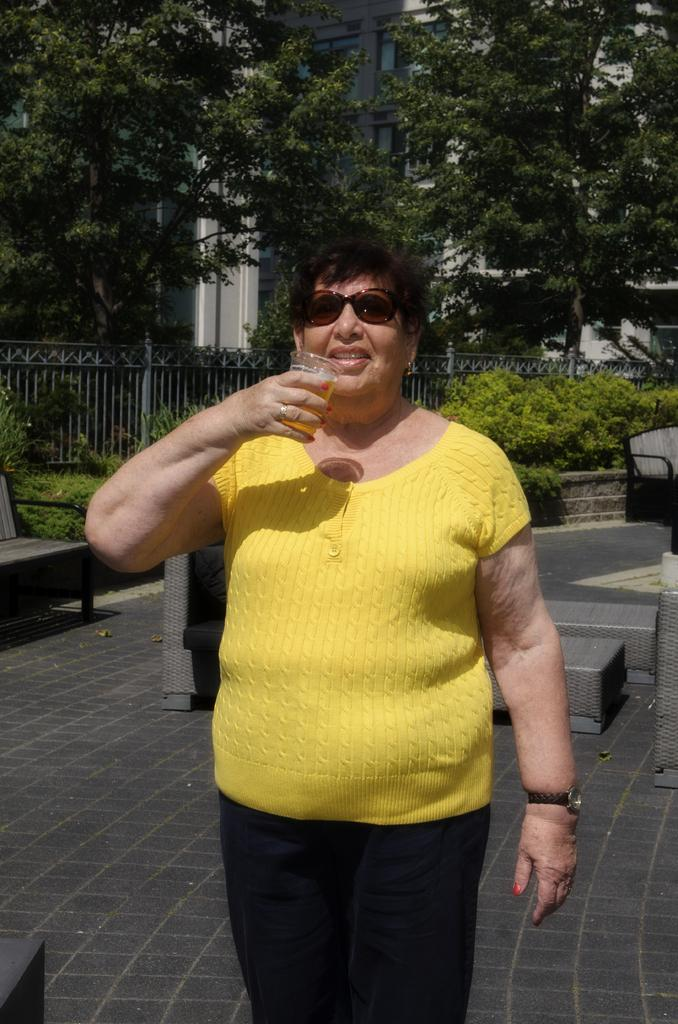Who is present in the image? There is a woman in the image. What is the woman holding in the image? The woman is holding a glass. Where is the woman standing in the image? The woman is standing on the floor. What can be seen on the left side of the image? There is a bench on the left side of the image. What type of structure is visible in the image? There is a fence visible in the image. What type of vegetation is present in the image? Bushes are present in the image. What type of natural elements can be seen in the image? Trees are visible in the image. What type of man-made structure is visible in the image? There is a building in the image. What type of mine is visible in the image? There is no mine present in the image. 